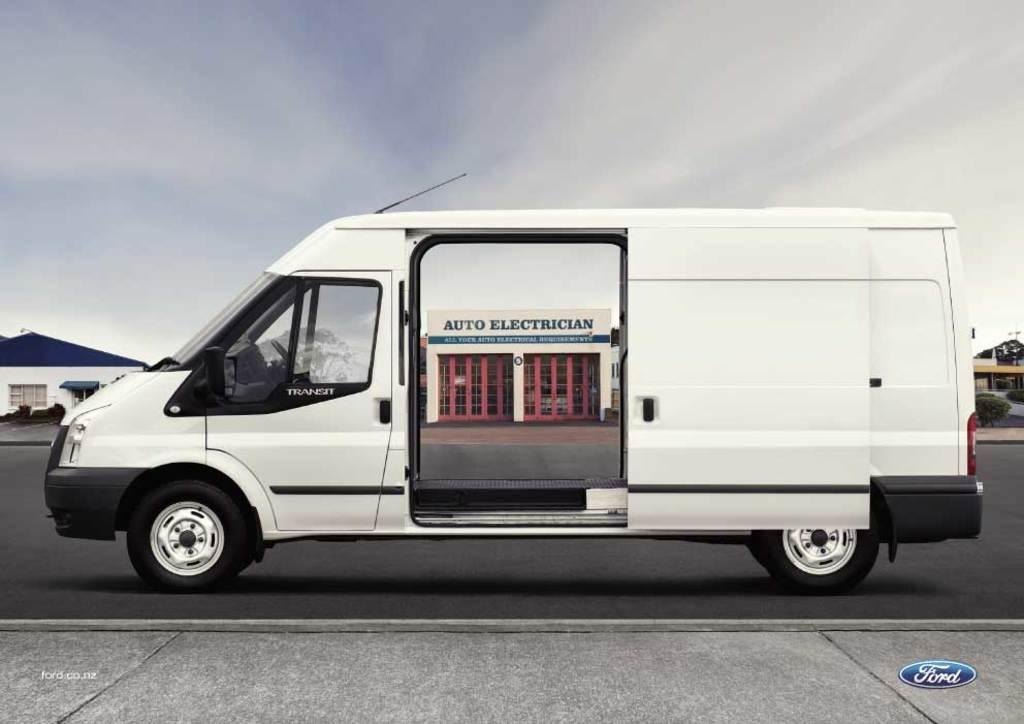<image>
Offer a succinct explanation of the picture presented. A white van with a sign that says auto electrician. 